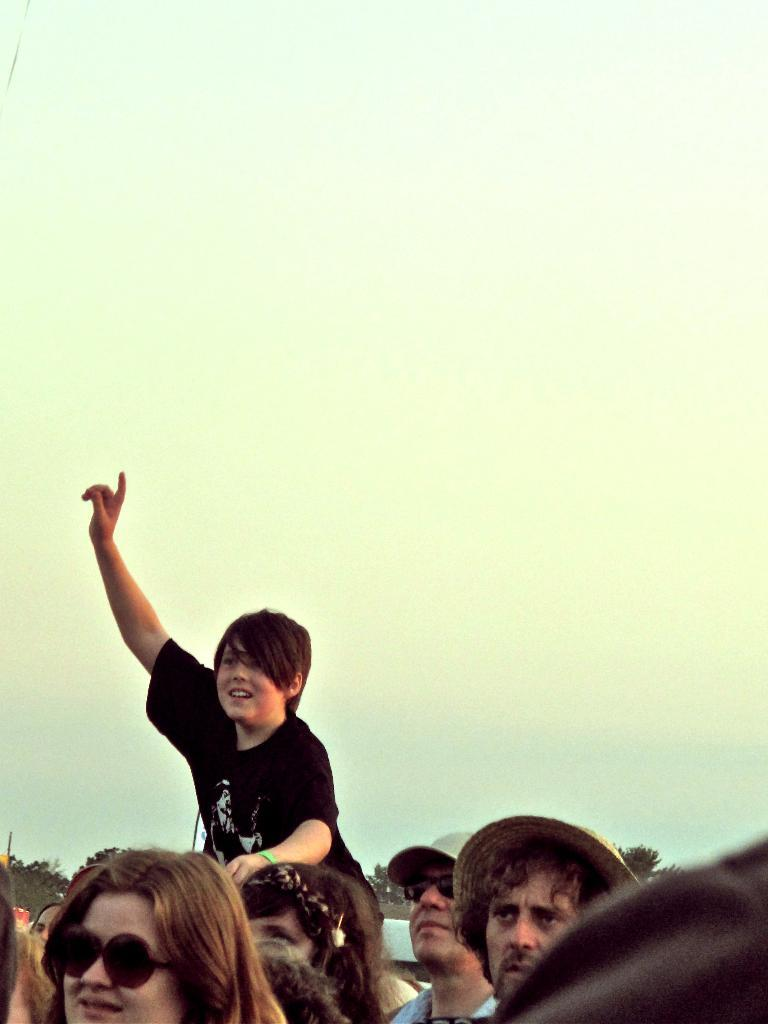How many people are present in the image? There are many people in the image. Can you describe the lady's attire in the image? The lady is wearing goggles. What type of headwear can be seen on some people in the background? Some people in the background are wearing caps and hats. What is the boy doing in the image? The boy is sitting on a person. What can be seen in the background of the image? The sky and trees are visible in the background of the image. What type of pump is being used to create ink in the image? There is no pump or ink present in the image. What advertisement can be seen on the side of the building in the image? There is no advertisement visible on any building in the image. 